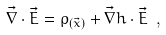Convert formula to latex. <formula><loc_0><loc_0><loc_500><loc_500>\vec { \nabla } \cdot \vec { E } = \rho _ { ( \vec { x } ) } + \vec { \nabla } h \cdot \vec { E } \ ,</formula> 